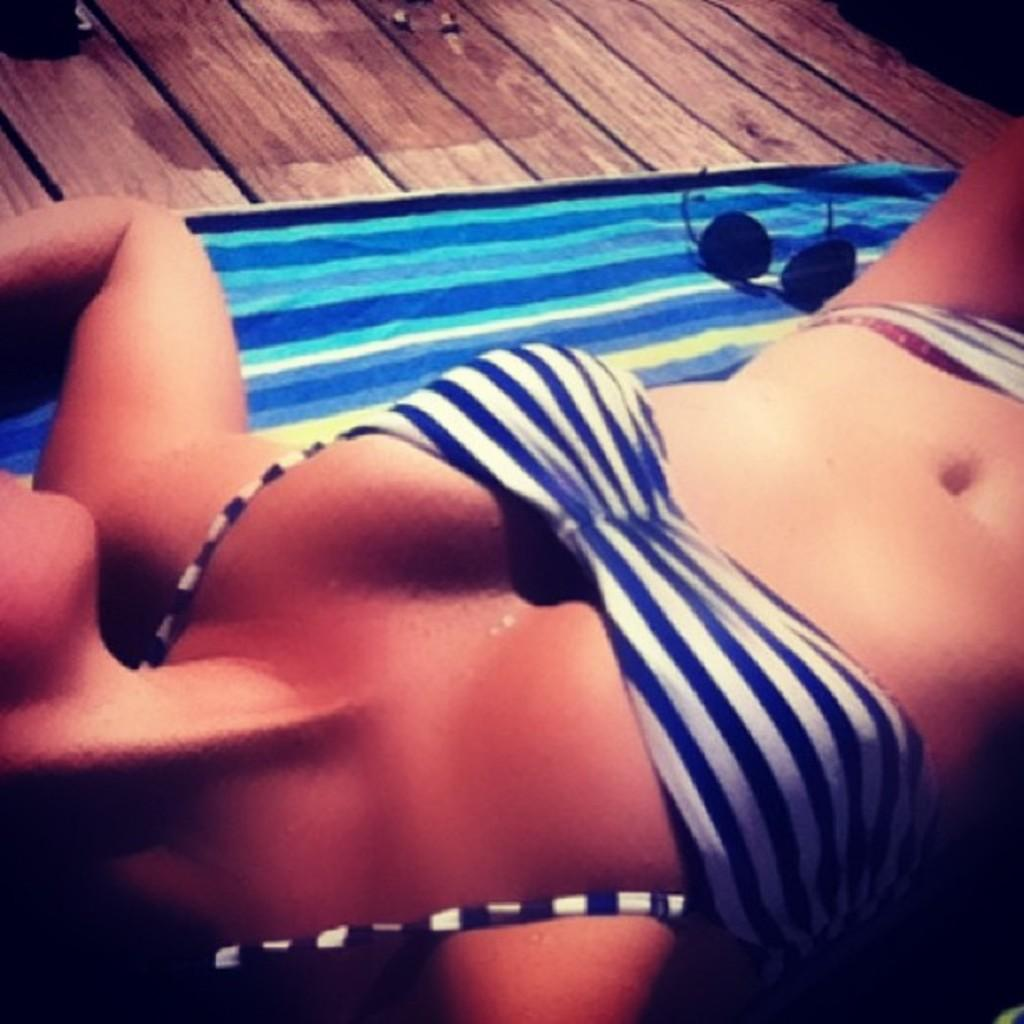What is the position of the woman in the image? There is a woman lying in the image. What object is present that might be used for drying or covering? There is a towel in the image. What item is visible that might be used for eye protection? There are goggles in the image. What material is the object at the bottom of the image made of? There is a wooden board at the bottom of the image. How many lakes can be seen in the image? There are no lakes present in the image. What type of scissors are being used by the woman in the image? There are no scissors visible in the image. 